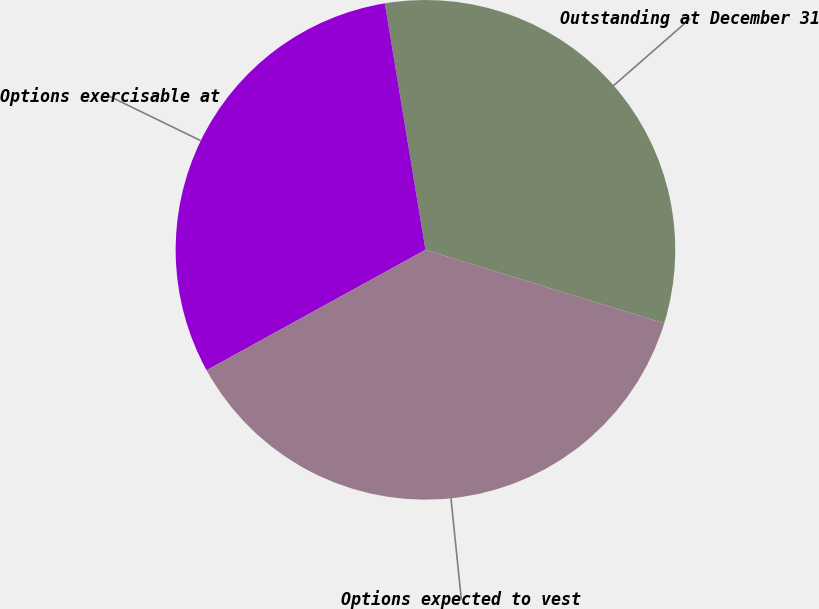<chart> <loc_0><loc_0><loc_500><loc_500><pie_chart><fcel>Outstanding at December 31<fcel>Options exercisable at<fcel>Options expected to vest<nl><fcel>32.35%<fcel>30.41%<fcel>37.24%<nl></chart> 